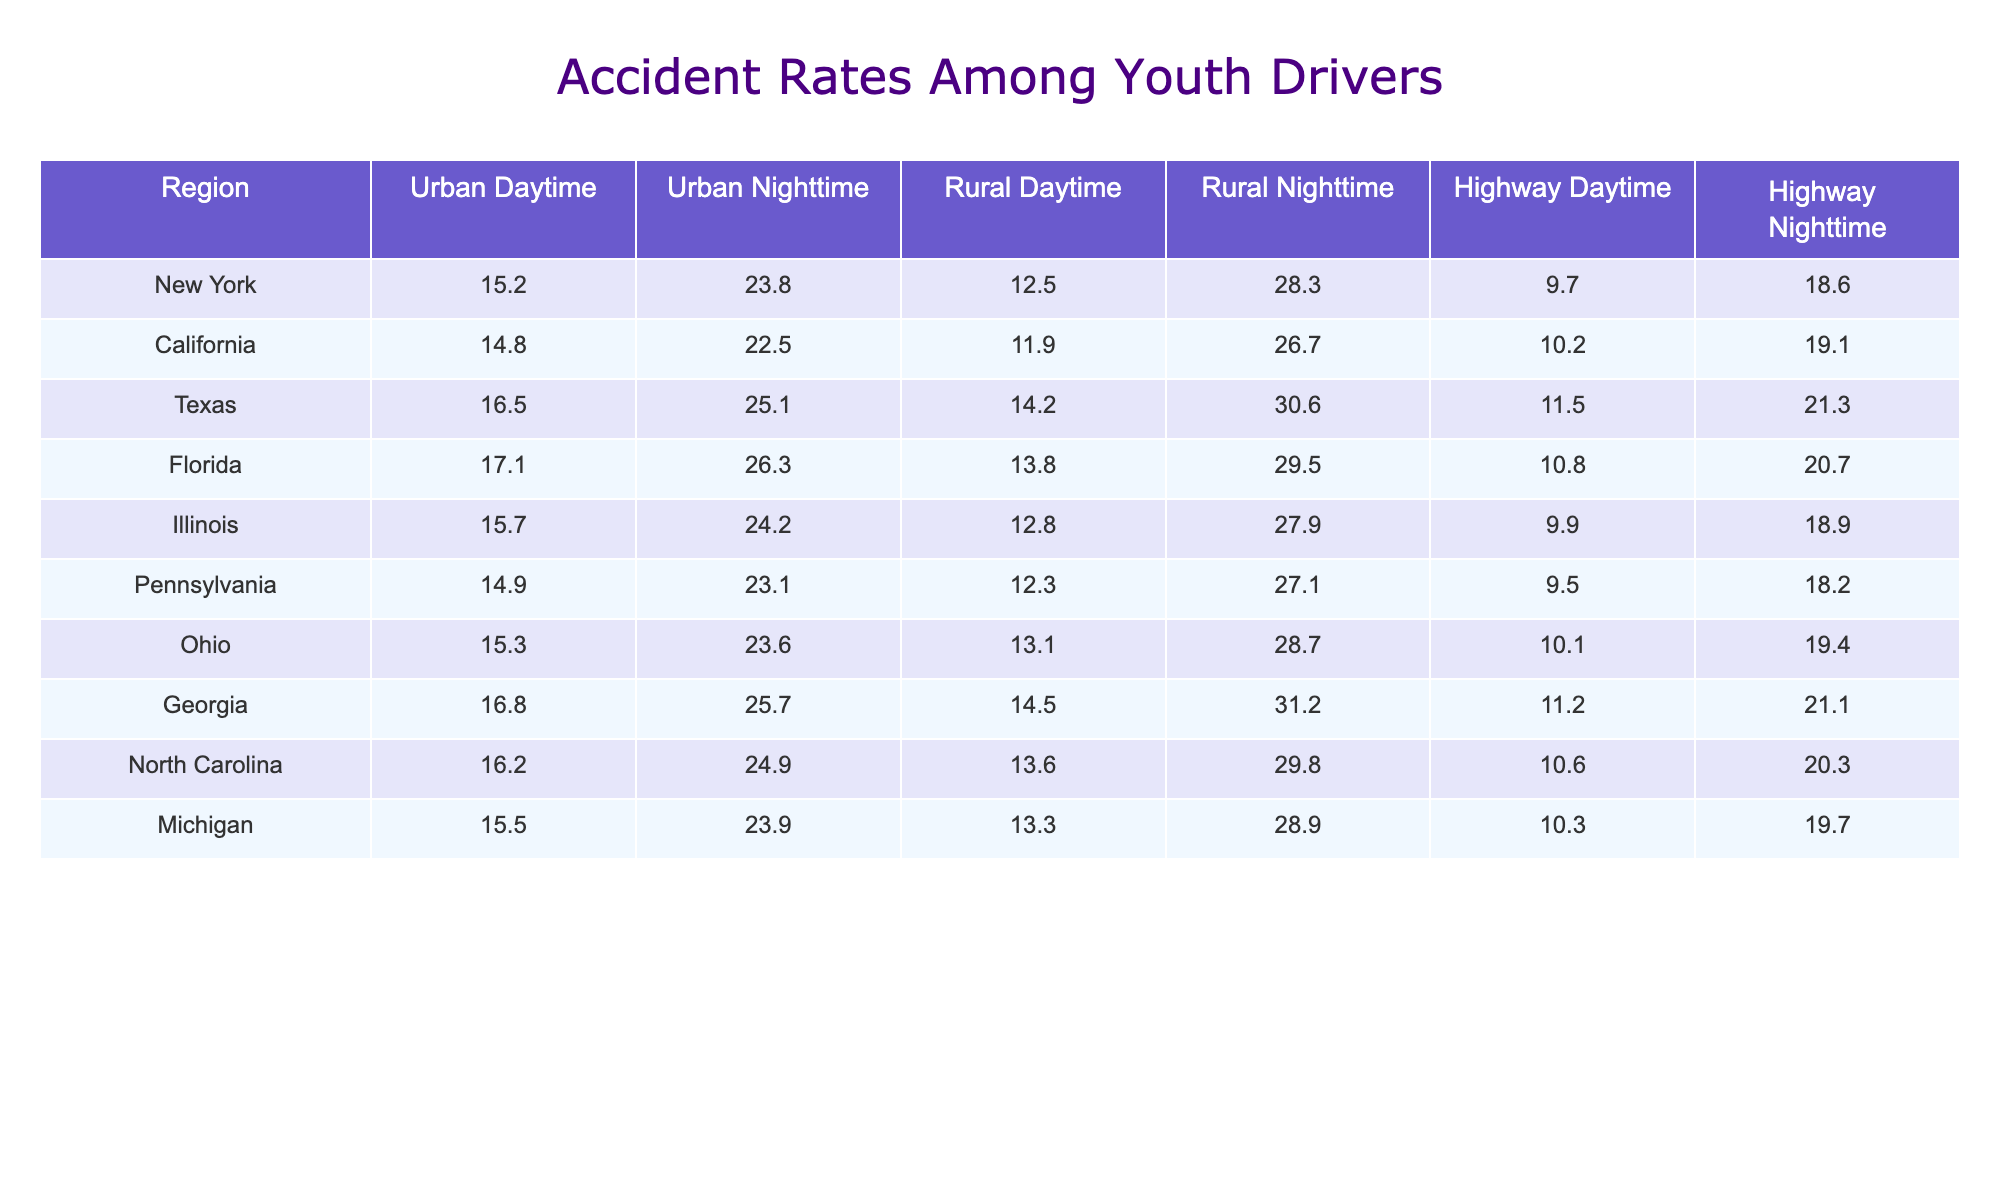What is the accident rate for youth drivers in New York during Urban Nighttime? The table shows the accident rate for New York under the Urban Nighttime condition as 23.8.
Answer: 23.8 Which region has the highest accident rate for youth drivers in Rural Nighttime? By comparing the Rural Nighttime values from the table, Texas has the highest accident rate at 30.6.
Answer: Texas What is the difference in accident rates for youth drivers between Urban Daytime and Urban Nighttime in California? The Urban Daytime rate in California is 14.8, and the Urban Nighttime rate is 22.5. The difference is 22.5 - 14.8 = 7.7.
Answer: 7.7 Is the accident rate for youth drivers in Florida higher during Rural Nighttime or Highway Nighttime? In Florida, the Rural Nighttime rate is 29.5 and the Highway Nighttime rate is 20.7. Hence, Rural Nighttime is higher.
Answer: Yes What is the average accident rate for youth drivers in Urban Daytime across all regions? The Urban Daytime rates are: 15.2, 14.8, 16.5, 17.1, 15.7, 14.9, 15.3, 16.8, 16.2, and 15.5. The sum is 15.2 + 14.8 + 16.5 + 17.1 + 15.7 + 14.9 + 15.3 + 16.8 + 16.2 + 15.5 =  164.8. There are 10 regions, so the average is 164.8 / 10 = 16.48.
Answer: 16.48 Which region has the lowest accident rate for youth drivers at Highway Nighttime? The Highway Nighttime values are as follows: New York 18.6, California 19.1, Texas 21.3, Florida 20.7, Illinois 18.9, Pennsylvania 18.2, Ohio 19.4, Georgia 21.1, North Carolina 20.3, and Michigan 19.7. The lowest value is 18.2 in Pennsylvania.
Answer: Pennsylvania What is the trend in accident rates for youth drivers between Urban and Rural driving conditions at Nighttime for Georgia? For Georgia, the Urban Nighttime rate is 25.7 and the Rural Nighttime rate is 31.2. The Rural Nighttime rate is higher, suggesting more accidents in that condition.
Answer: Higher in Rural Nighttime How does the accident rate for youth drivers in Texas during Urban Nighttime compare to that in Ohio during the same condition? Texas has a rate of 25.1 while Ohio has 23.6 during Urban Nighttime. Therefore, Texas's rate is higher.
Answer: Texas's rate is higher What is the sum of the accident rates for youth drivers during Highway Daytime across all regions? The Highway Daytime rates are: 9.7, 10.2, 11.5, 10.8, 9.9, 9.5, 10.1, 11.2, 10.6, and 10.3. The sum is 9.7 + 10.2 + 11.5 + 10.8 + 9.9 + 9.5 + 10.1 + 11.2 + 10.6 + 10.3 =  10.48.
Answer: 10.48 Which region has the second highest accident rate for youth drivers during Urban Daytime? The Urban Daytime rates in descending order show Texas (16.5) as the highest and Florida (17.1) as second. Thus, the second highest rate is Florida.
Answer: Florida 